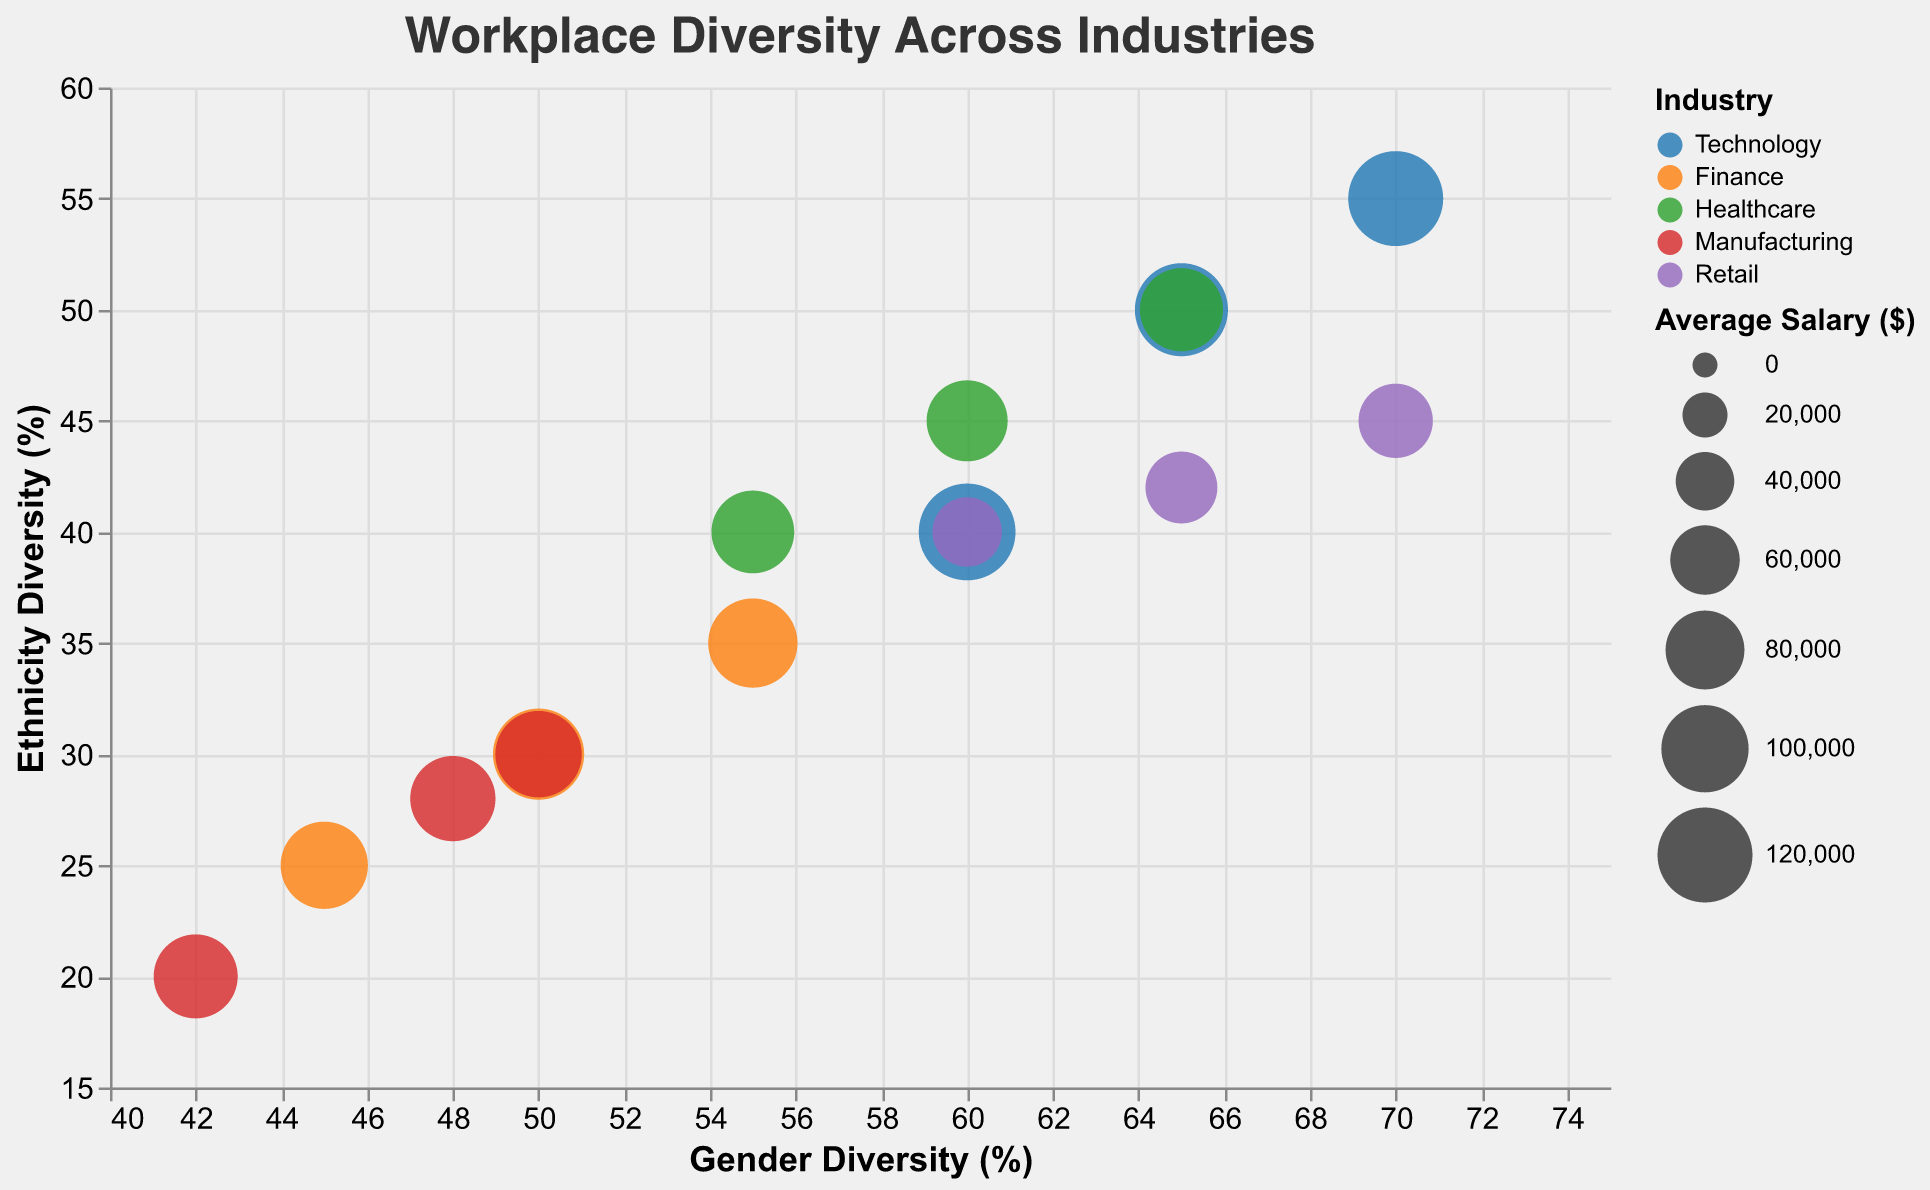What is the title of the chart? The title of the chart is usually displayed at the top of the visual. According to the provided code, the title is "Workplace Diversity Across Industries".
Answer: Workplace Diversity Across Industries Which industry has the highest gender diversity? The highest gender diversity is marked by the circle that is farthest to the right on the horizontal (x) axis, which is titled "Gender Diversity (%)". According to the data, Amazon and Google, both in the Retail and Technology industries respectively, have the highest gender diversity at 70%.
Answer: Technology and Retail (Amazon, Google) Which company in the Finance industry has the lowest ethnicity diversity? To find the Finance company with the lowest ethnicity diversity, look for the Finance circles at the lowest point on the vertical (y) axis, titled "Ethnicity Diversity (%)". According to the data, HSBC has the lowest ethnicity diversity in the Finance industry at 25%.
Answer: HSBC What is the average gender diversity across all companies shown in the chart? To calculate the average gender diversity, add up the gender diversity percentages of all companies and divide by the number of companies. The numbers are 70, 65, 60, 50, 55, 45, 60, 65, 55, 48, 42, 50, 60, 70, 65 for a total of 15 companies. Therefore, (70+65+60+50+55+45+60+65+55+48+42+50+60+70+65)/15 = 58.67%.
Answer: 58.67% Compare the average salaries of the companies in the Technology and Healthcare industries. Which industry has a higher average salary? To compare average salaries, calculate the average salary within each industry by summing the salaries and dividing by the number of companies in each. Technology: (120000 + 115000 + 125000)/3 = 120000. Healthcare: (85000 + 90000 + 89000)/3 = 88000. So, Technology has a higher average salary.
Answer: Technology Which company has the highest average salary and what is its gender and ethnicity diversity percentage? The size of the circle represents the average salary. The largest circle corresponds to the company with the highest salary. According to the data, Apple has the highest average salary ($125,000) with a gender diversity of 60% and ethnicity diversity of 40%.
Answer: Apple, 60% gender diversity, 40% ethnicity diversity How does Walmart compare to Amazon in terms of gender and ethnicity diversity? By comparing the positions of Walmart and Amazon on the chart, Walmart has a gender diversity of 60% and ethnicity diversity of 40%, whereas Amazon has a gender diversity of 70% and ethnicity diversity of 45%.
Answer: Amazon has higher gender and ethnicity diversity than Walmart Among the companies in the Manufacturing industry, which one has the highest gender diversity and what is its average salary? In the Manufacturing industry, look for the company represented by the circle farthest to the right on the horizontal axis (Gender Diversity). Boeing has the highest gender diversity at 50%, with an average salary of $98,000.
Answer: Boeing, $98,000 Which companies have exactly 50% gender diversity? To find the companies with exactly 50% gender diversity, locate the circles aligned with the 50% mark on the horizontal axis. These companies are Goldman Sachs and Boeing.
Answer: Goldman Sachs and Boeing Calculate the difference in ethnicity diversity between the company with the highest gender diversity and the company with the highest average salary. The company with the highest gender diversity is Google's 70% (at its highest), and the company with the highest average salary is Apple ($125,000) with an ethnicity diversity of 40%. Google's ethnicity diversity is 55%. The difference is 55% - 40% = 15%.
Answer: 15% 